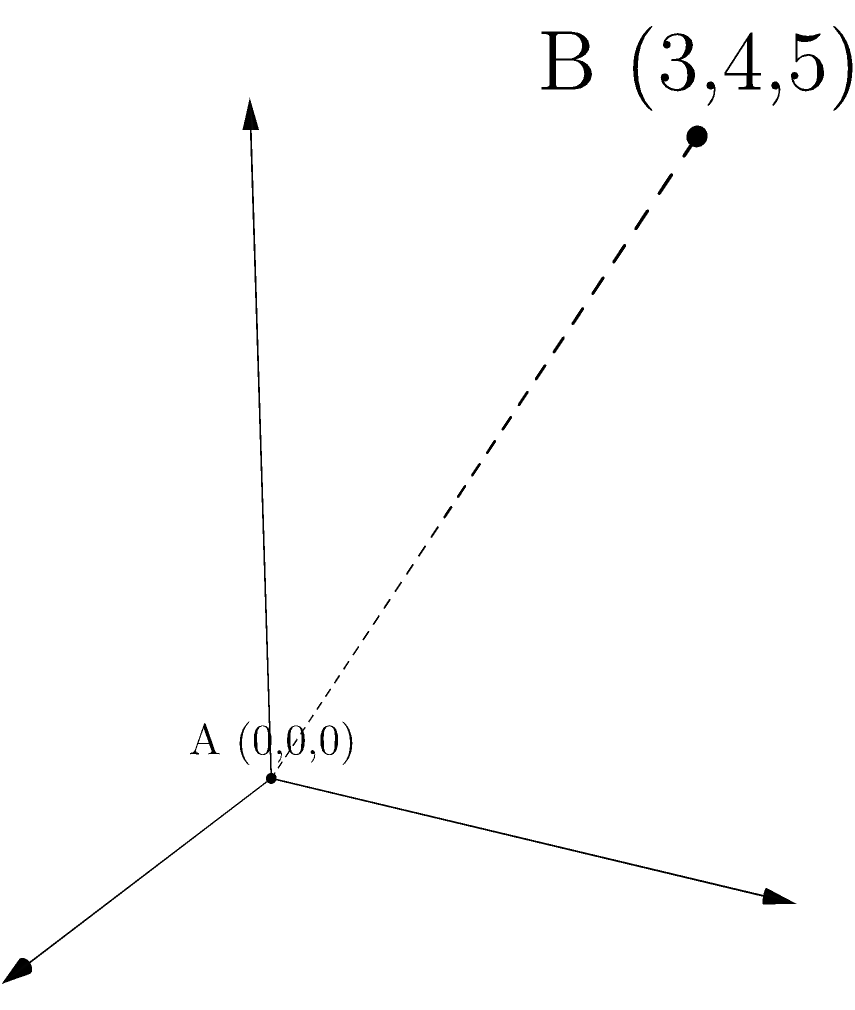Two planets are located in a 3D coordinate system. Planet A is at the origin (0,0,0), and Planet B is at coordinates (3,4,5). Calculate the distance between these two planets using the three-dimensional distance formula. To calculate the distance between two points in a 3D coordinate system, we use the three-dimensional distance formula:

$$d = \sqrt{(x_2-x_1)^2 + (y_2-y_1)^2 + (z_2-z_1)^2}$$

Where $(x_1,y_1,z_1)$ are the coordinates of the first point and $(x_2,y_2,z_2)$ are the coordinates of the second point.

Given:
Planet A: $(x_1,y_1,z_1) = (0,0,0)$
Planet B: $(x_2,y_2,z_2) = (3,4,5)$

Step 1: Substitute the values into the formula:
$$d = \sqrt{(3-0)^2 + (4-0)^2 + (5-0)^2}$$

Step 2: Simplify the expressions inside the parentheses:
$$d = \sqrt{3^2 + 4^2 + 5^2}$$

Step 3: Calculate the squares:
$$d = \sqrt{9 + 16 + 25}$$

Step 4: Sum the values under the square root:
$$d = \sqrt{50}$$

Step 5: Simplify the square root:
$$d = 5\sqrt{2}$$

Therefore, the distance between Planet A and Planet B is $5\sqrt{2}$ units.
Answer: $5\sqrt{2}$ units 